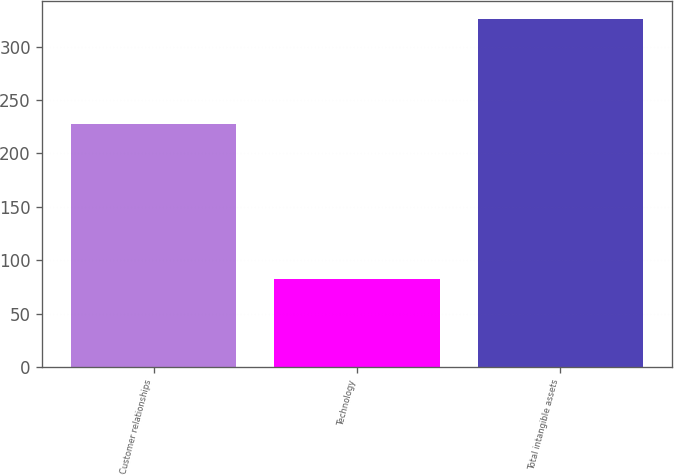Convert chart to OTSL. <chart><loc_0><loc_0><loc_500><loc_500><bar_chart><fcel>Customer relationships<fcel>Technology<fcel>Total intangible assets<nl><fcel>228<fcel>82<fcel>326<nl></chart> 